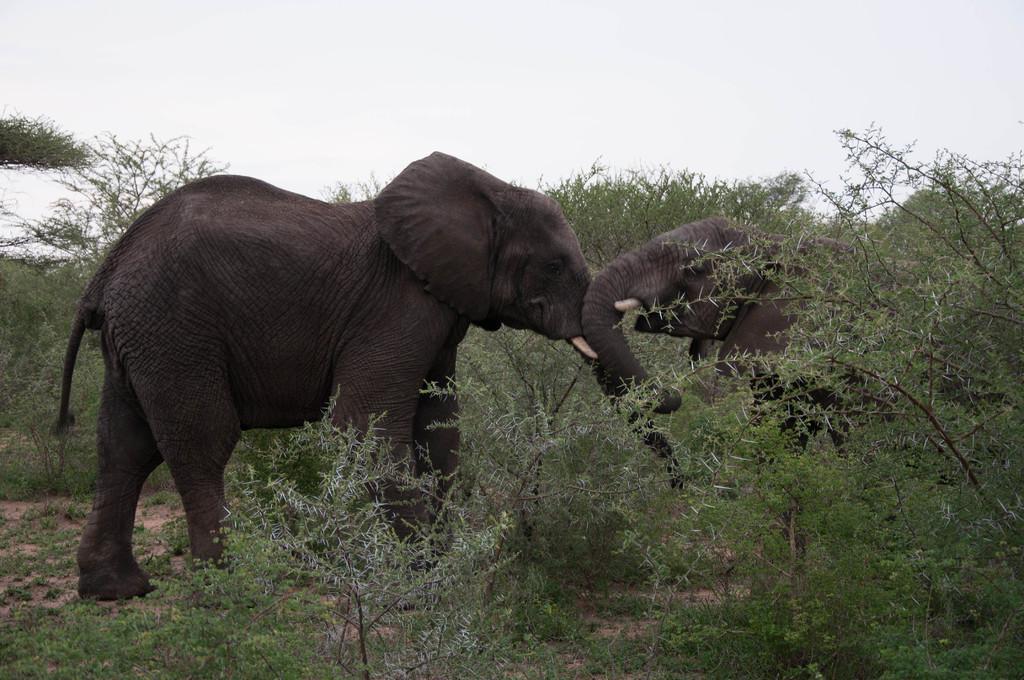Could you give a brief overview of what you see in this image? In this picture we can see the grass, two elephants and trees. In the background we can see the sky. 